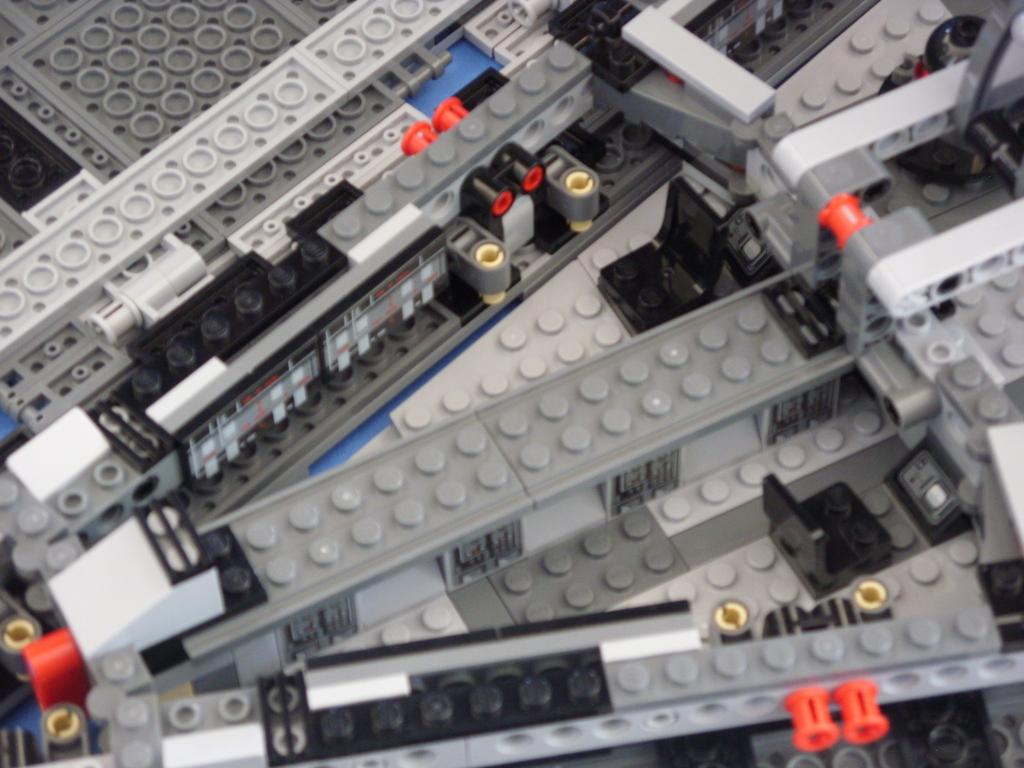What is the main subject of the image? The main subject of the image is lego toys. Where are the lego toys located in the image? The lego toys are in the center of the image. What team is responsible for moving the lego toys in the image? There is no team present in the image, and the lego toys are not moving. 